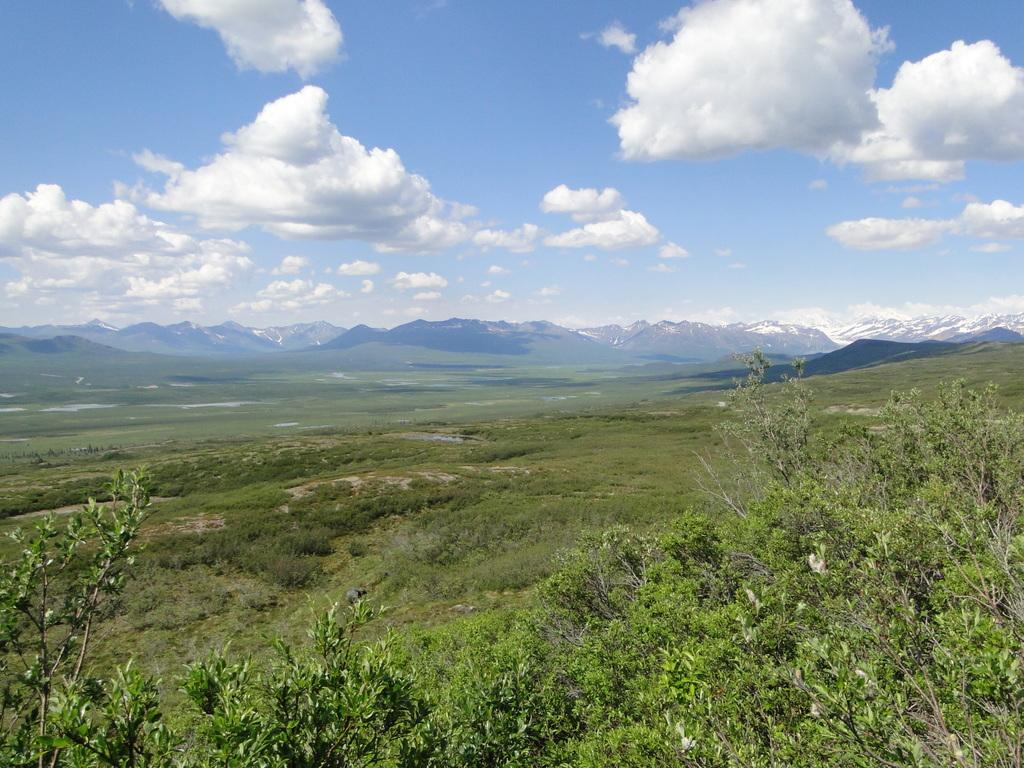What type of vegetation can be seen in the image? There are trees in the image. What geographical feature is visible in the image? There are mountains in the image. What type of ground cover is present in the image? There is grass in the image. What can be seen in the background of the image? The sky is visible in the background of the image. What atmospheric conditions are present in the sky? Clouds are present in the sky. Can you see any wings on the trees in the image? There are no wings present on the trees in the image. What type of beast can be seen roaming among the mountains in the image? There are no beasts present in the image; it features trees, mountains, grass, and clouds. 